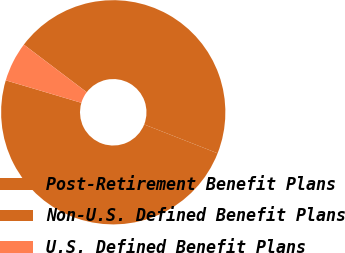Convert chart to OTSL. <chart><loc_0><loc_0><loc_500><loc_500><pie_chart><fcel>Post-Retirement Benefit Plans<fcel>Non-U.S. Defined Benefit Plans<fcel>U.S. Defined Benefit Plans<nl><fcel>48.64%<fcel>45.65%<fcel>5.71%<nl></chart> 